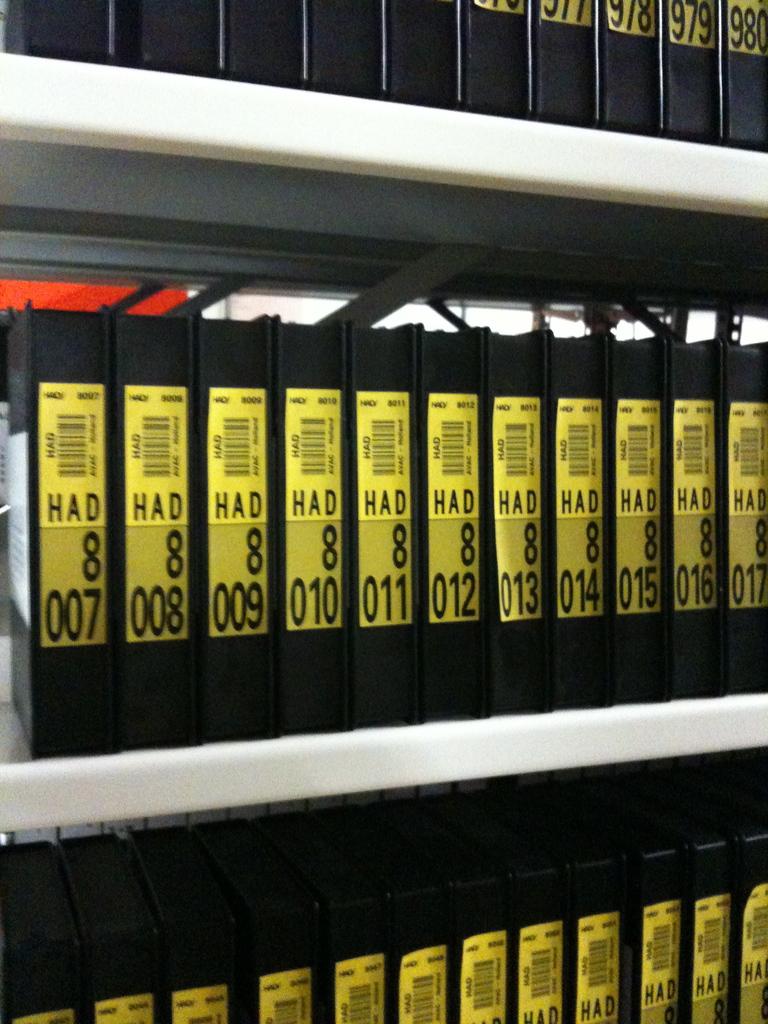Are these objects in their proper numerical order?
Offer a terse response. Yes. How many times can you see the number eight?
Provide a succinct answer. 12. 